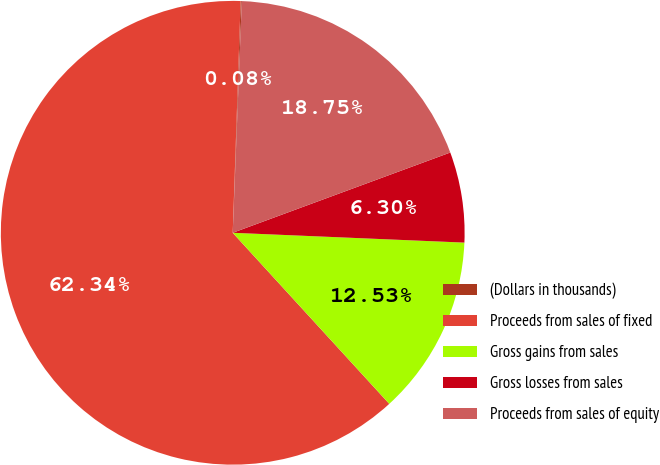<chart> <loc_0><loc_0><loc_500><loc_500><pie_chart><fcel>(Dollars in thousands)<fcel>Proceeds from sales of fixed<fcel>Gross gains from sales<fcel>Gross losses from sales<fcel>Proceeds from sales of equity<nl><fcel>0.08%<fcel>62.34%<fcel>12.53%<fcel>6.3%<fcel>18.75%<nl></chart> 